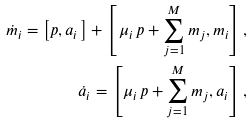<formula> <loc_0><loc_0><loc_500><loc_500>\dot { m } _ { i } = \left [ { p } , { a } _ { i } \, \right ] + \left [ \, \mu _ { i } \, { p } + \sum _ { j = 1 } ^ { M } { m } _ { j } , { m } _ { i } \right ] , \\ \dot { a } _ { i } = \left [ \mu _ { i } \, { p } + \sum _ { j = 1 } ^ { M } { m } _ { j } , { a } _ { i } \right ] ,</formula> 